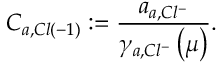<formula> <loc_0><loc_0><loc_500><loc_500>C _ { a , C l \left ( - 1 \right ) } \colon = \frac { a _ { a , C l ^ { - } } } { \gamma _ { a , C l ^ { - } } \left ( \mu \right ) } .</formula> 